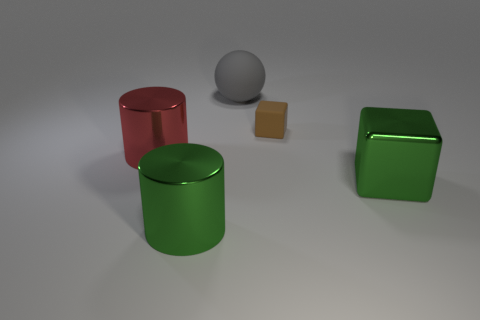Does the large metallic thing that is to the right of the big matte sphere have the same color as the rubber thing on the left side of the brown rubber cube?
Your answer should be very brief. No. Are there any big gray rubber things in front of the large gray rubber thing that is behind the brown block?
Make the answer very short. No. Is the number of gray things that are in front of the large metal block less than the number of tiny brown rubber blocks that are on the left side of the red thing?
Offer a terse response. No. Is the big object that is in front of the large cube made of the same material as the cylinder that is behind the big cube?
Your answer should be compact. Yes. How many small things are gray metallic objects or spheres?
Keep it short and to the point. 0. What is the shape of the small object that is the same material as the big gray sphere?
Provide a succinct answer. Cube. Are there fewer large green blocks that are behind the rubber ball than large blue balls?
Your answer should be compact. No. Does the red object have the same shape as the small matte object?
Give a very brief answer. No. How many matte objects are small brown blocks or large gray balls?
Provide a short and direct response. 2. Is there a gray shiny ball that has the same size as the brown rubber object?
Your response must be concise. No. 